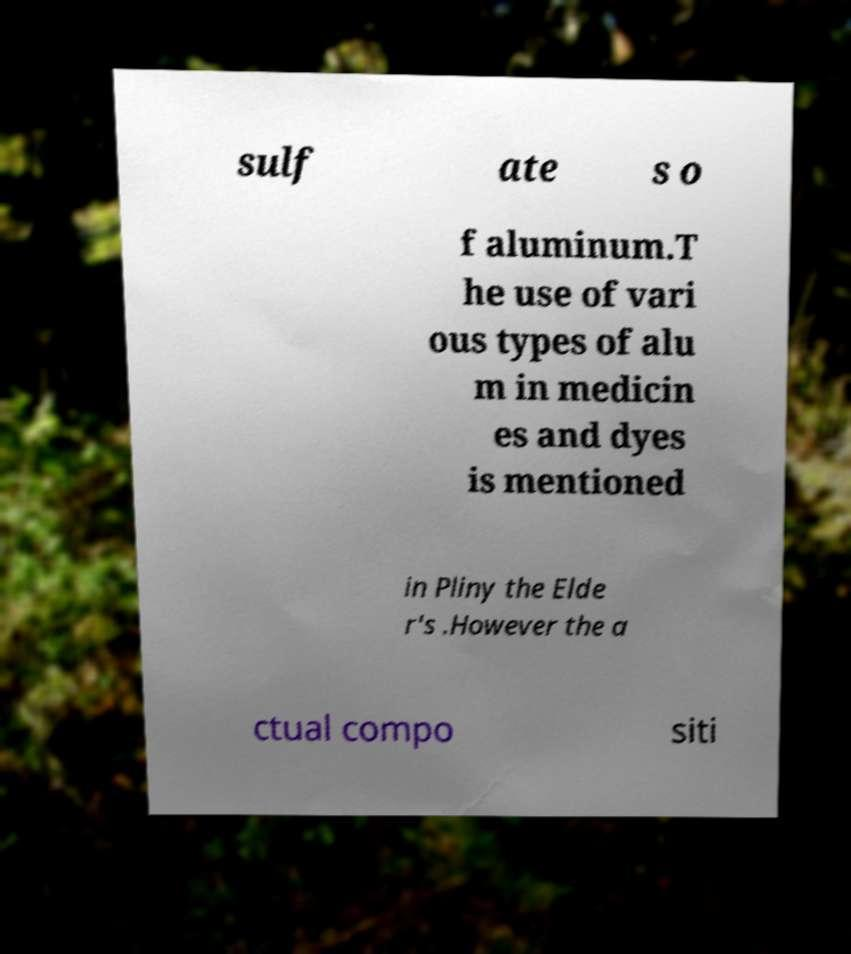Can you accurately transcribe the text from the provided image for me? sulf ate s o f aluminum.T he use of vari ous types of alu m in medicin es and dyes is mentioned in Pliny the Elde r's .However the a ctual compo siti 